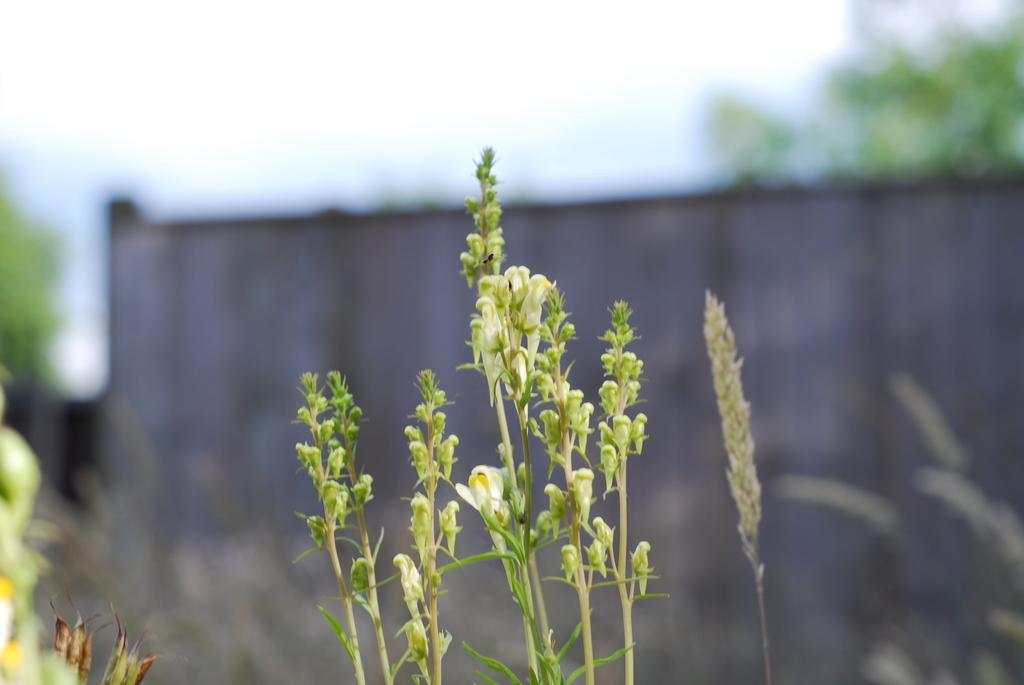What type of vegetation can be seen in the image? There are trees in the image. What other objects or features are present in the image? There are planets with flowers in the image. What is the background or setting of the image? There is a wall in the image. What type of berry is growing on the ground in the image? There is no berry growing on the ground in the image. What type of fuel is being used by the planets in the image? The planets in the image are not actual celestial bodies, but rather representations with flowers, so they do not require fuel. 